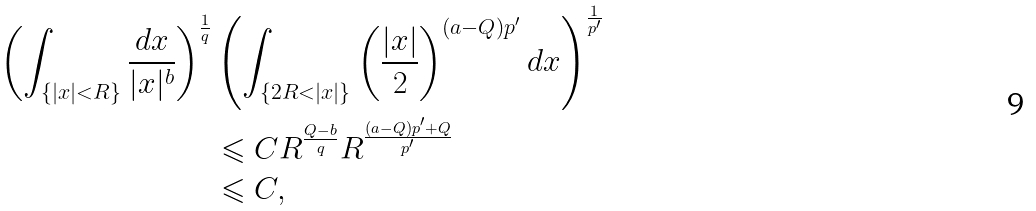<formula> <loc_0><loc_0><loc_500><loc_500>\left ( \int _ { \{ | x | < R \} } \frac { d x } { | x | ^ { b } } \right ) ^ { \frac { 1 } { q } } & \left ( \int _ { \{ 2 R < | x | \} } \left ( \frac { | x | } { 2 } \right ) ^ { ( a - Q ) p ^ { \prime } } d x \right ) ^ { \frac { 1 } { p ^ { \prime } } } \\ & \leqslant C R ^ { \frac { Q - b } { q } } R ^ { \frac { ( a - Q ) p ^ { \prime } + Q } { p ^ { \prime } } } \\ & \leqslant C ,</formula> 